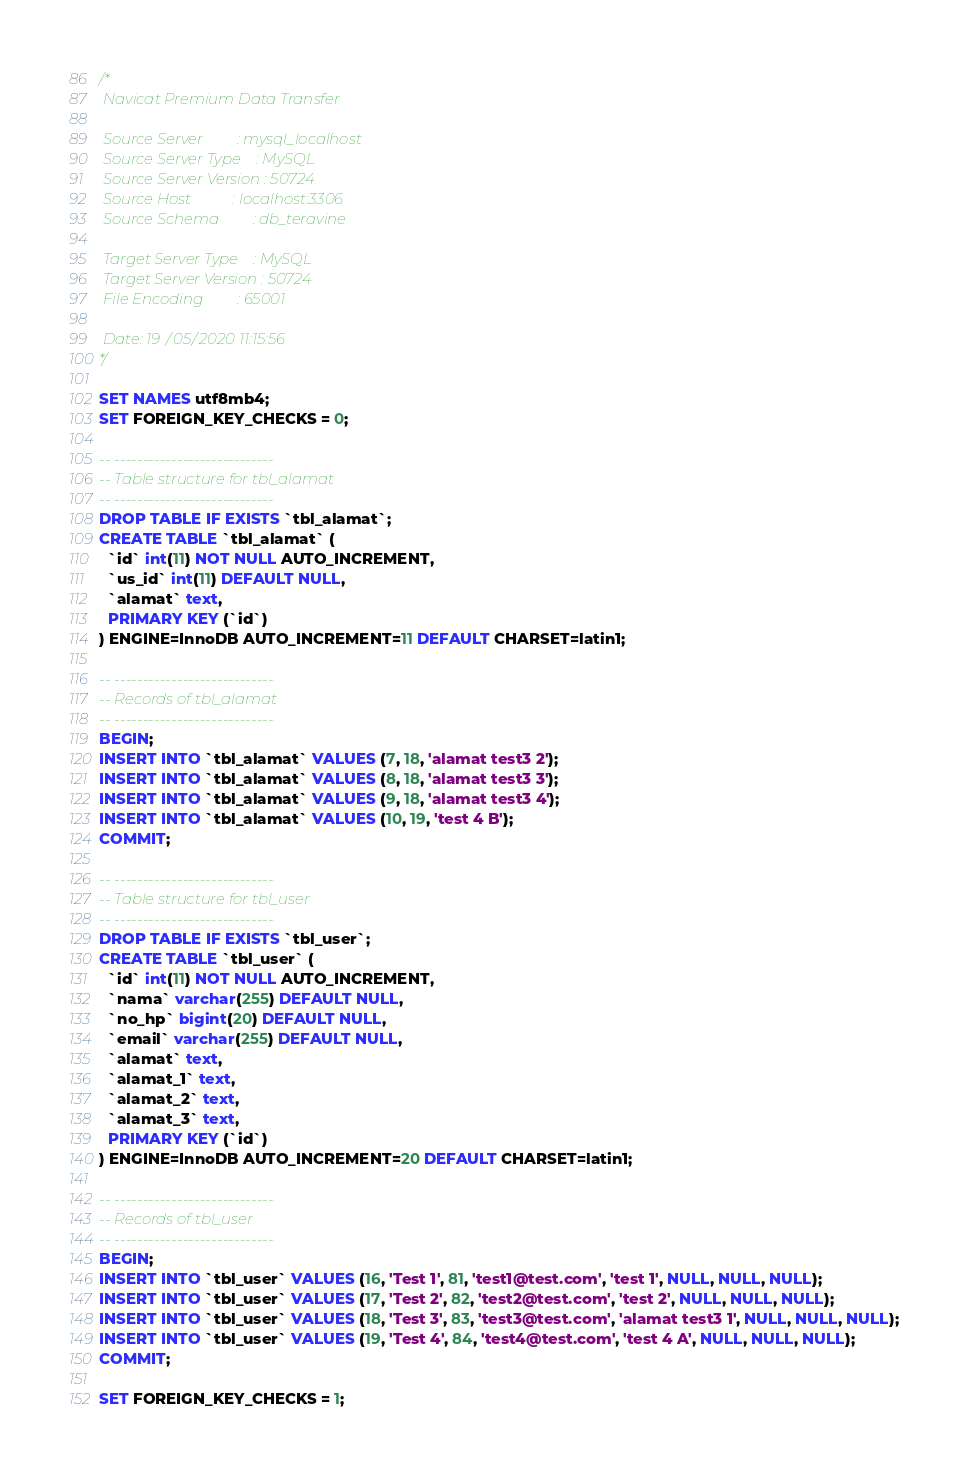Convert code to text. <code><loc_0><loc_0><loc_500><loc_500><_SQL_>/*
 Navicat Premium Data Transfer

 Source Server         : mysql_localhost
 Source Server Type    : MySQL
 Source Server Version : 50724
 Source Host           : localhost:3306
 Source Schema         : db_teravine

 Target Server Type    : MySQL
 Target Server Version : 50724
 File Encoding         : 65001

 Date: 19/05/2020 11:15:56
*/

SET NAMES utf8mb4;
SET FOREIGN_KEY_CHECKS = 0;

-- ----------------------------
-- Table structure for tbl_alamat
-- ----------------------------
DROP TABLE IF EXISTS `tbl_alamat`;
CREATE TABLE `tbl_alamat` (
  `id` int(11) NOT NULL AUTO_INCREMENT,
  `us_id` int(11) DEFAULT NULL,
  `alamat` text,
  PRIMARY KEY (`id`)
) ENGINE=InnoDB AUTO_INCREMENT=11 DEFAULT CHARSET=latin1;

-- ----------------------------
-- Records of tbl_alamat
-- ----------------------------
BEGIN;
INSERT INTO `tbl_alamat` VALUES (7, 18, 'alamat test3 2');
INSERT INTO `tbl_alamat` VALUES (8, 18, 'alamat test3 3');
INSERT INTO `tbl_alamat` VALUES (9, 18, 'alamat test3 4');
INSERT INTO `tbl_alamat` VALUES (10, 19, 'test 4 B');
COMMIT;

-- ----------------------------
-- Table structure for tbl_user
-- ----------------------------
DROP TABLE IF EXISTS `tbl_user`;
CREATE TABLE `tbl_user` (
  `id` int(11) NOT NULL AUTO_INCREMENT,
  `nama` varchar(255) DEFAULT NULL,
  `no_hp` bigint(20) DEFAULT NULL,
  `email` varchar(255) DEFAULT NULL,
  `alamat` text,
  `alamat_1` text,
  `alamat_2` text,
  `alamat_3` text,
  PRIMARY KEY (`id`)
) ENGINE=InnoDB AUTO_INCREMENT=20 DEFAULT CHARSET=latin1;

-- ----------------------------
-- Records of tbl_user
-- ----------------------------
BEGIN;
INSERT INTO `tbl_user` VALUES (16, 'Test 1', 81, 'test1@test.com', 'test 1', NULL, NULL, NULL);
INSERT INTO `tbl_user` VALUES (17, 'Test 2', 82, 'test2@test.com', 'test 2', NULL, NULL, NULL);
INSERT INTO `tbl_user` VALUES (18, 'Test 3', 83, 'test3@test.com', 'alamat test3 1', NULL, NULL, NULL);
INSERT INTO `tbl_user` VALUES (19, 'Test 4', 84, 'test4@test.com', 'test 4 A', NULL, NULL, NULL);
COMMIT;

SET FOREIGN_KEY_CHECKS = 1;
</code> 